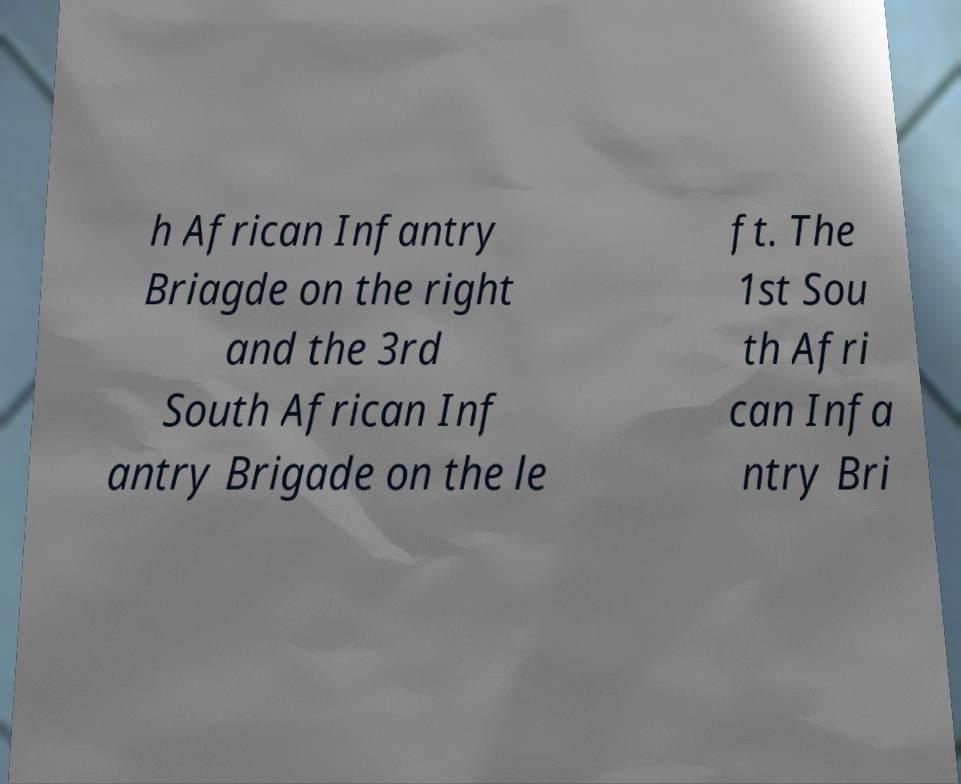For documentation purposes, I need the text within this image transcribed. Could you provide that? h African Infantry Briagde on the right and the 3rd South African Inf antry Brigade on the le ft. The 1st Sou th Afri can Infa ntry Bri 